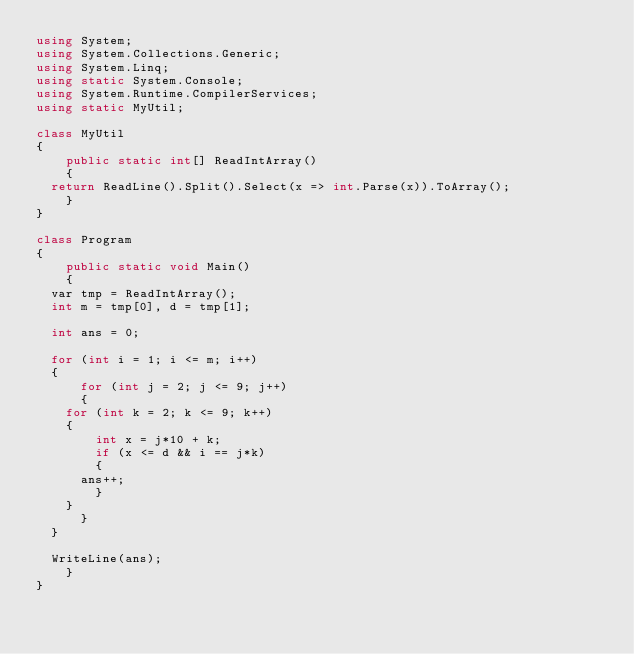<code> <loc_0><loc_0><loc_500><loc_500><_C#_>using System;
using System.Collections.Generic;
using System.Linq;
using static System.Console;
using System.Runtime.CompilerServices;
using static MyUtil;

class MyUtil
{
    public static int[] ReadIntArray()
    {
	return ReadLine().Split().Select(x => int.Parse(x)).ToArray();
    }
}

class Program
{
    public static void Main()
    {
	var tmp = ReadIntArray();
	int m = tmp[0], d = tmp[1];

	int ans = 0;

	for (int i = 1; i <= m; i++)
	{
	    for (int j = 2; j <= 9; j++)
	    {
		for (int k = 2; k <= 9; k++)
		{
		    int x = j*10 + k;
		    if (x <= d && i == j*k)
		    {
			ans++;
		    }
		}
	    }
	}

	WriteLine(ans);
    }
}
</code> 